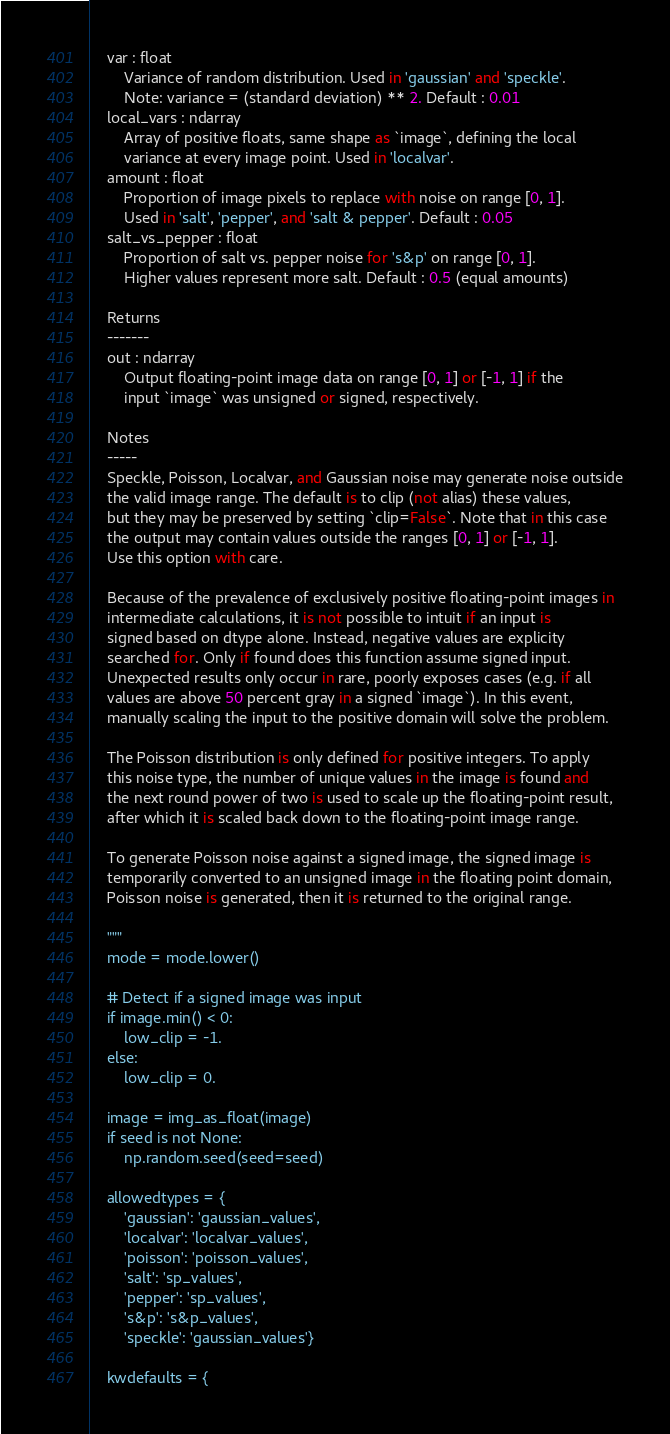<code> <loc_0><loc_0><loc_500><loc_500><_Python_>    var : float
        Variance of random distribution. Used in 'gaussian' and 'speckle'.
        Note: variance = (standard deviation) ** 2. Default : 0.01
    local_vars : ndarray
        Array of positive floats, same shape as `image`, defining the local
        variance at every image point. Used in 'localvar'.
    amount : float
        Proportion of image pixels to replace with noise on range [0, 1].
        Used in 'salt', 'pepper', and 'salt & pepper'. Default : 0.05
    salt_vs_pepper : float
        Proportion of salt vs. pepper noise for 's&p' on range [0, 1].
        Higher values represent more salt. Default : 0.5 (equal amounts)

    Returns
    -------
    out : ndarray
        Output floating-point image data on range [0, 1] or [-1, 1] if the
        input `image` was unsigned or signed, respectively.

    Notes
    -----
    Speckle, Poisson, Localvar, and Gaussian noise may generate noise outside
    the valid image range. The default is to clip (not alias) these values,
    but they may be preserved by setting `clip=False`. Note that in this case
    the output may contain values outside the ranges [0, 1] or [-1, 1].
    Use this option with care.

    Because of the prevalence of exclusively positive floating-point images in
    intermediate calculations, it is not possible to intuit if an input is
    signed based on dtype alone. Instead, negative values are explicity
    searched for. Only if found does this function assume signed input.
    Unexpected results only occur in rare, poorly exposes cases (e.g. if all
    values are above 50 percent gray in a signed `image`). In this event,
    manually scaling the input to the positive domain will solve the problem.

    The Poisson distribution is only defined for positive integers. To apply
    this noise type, the number of unique values in the image is found and
    the next round power of two is used to scale up the floating-point result,
    after which it is scaled back down to the floating-point image range.

    To generate Poisson noise against a signed image, the signed image is
    temporarily converted to an unsigned image in the floating point domain,
    Poisson noise is generated, then it is returned to the original range.

    """
    mode = mode.lower()

    # Detect if a signed image was input
    if image.min() < 0:
        low_clip = -1.
    else:
        low_clip = 0.

    image = img_as_float(image)
    if seed is not None:
        np.random.seed(seed=seed)

    allowedtypes = {
        'gaussian': 'gaussian_values',
        'localvar': 'localvar_values',
        'poisson': 'poisson_values',
        'salt': 'sp_values',
        'pepper': 'sp_values',
        's&p': 's&p_values',
        'speckle': 'gaussian_values'}

    kwdefaults = {</code> 